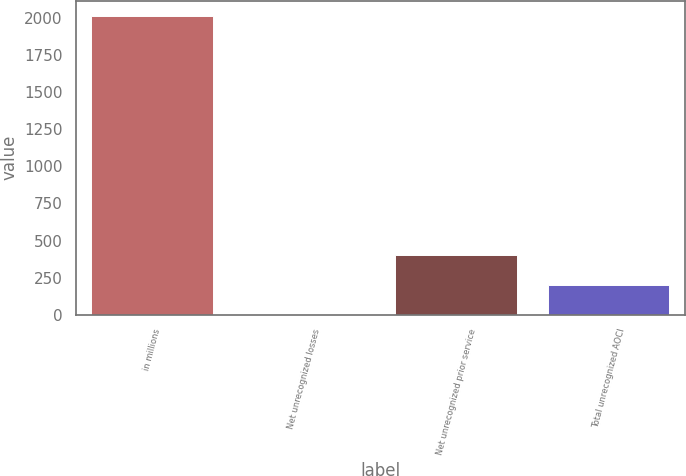<chart> <loc_0><loc_0><loc_500><loc_500><bar_chart><fcel>in millions<fcel>Net unrecognized losses<fcel>Net unrecognized prior service<fcel>Total unrecognized AOCI<nl><fcel>2014<fcel>2<fcel>404.4<fcel>203.2<nl></chart> 